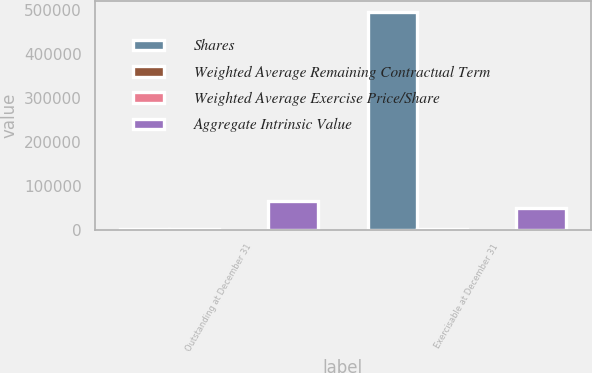Convert chart to OTSL. <chart><loc_0><loc_0><loc_500><loc_500><stacked_bar_chart><ecel><fcel>Outstanding at December 31<fcel>Exercisable at December 31<nl><fcel>Shares<fcel>85.61<fcel>495334<nl><fcel>Weighted Average Remaining Contractual Term<fcel>85.61<fcel>84.94<nl><fcel>Weighted Average Exercise Price/Share<fcel>4.5<fcel>4.1<nl><fcel>Aggregate Intrinsic Value<fcel>64352<fcel>49517<nl></chart> 